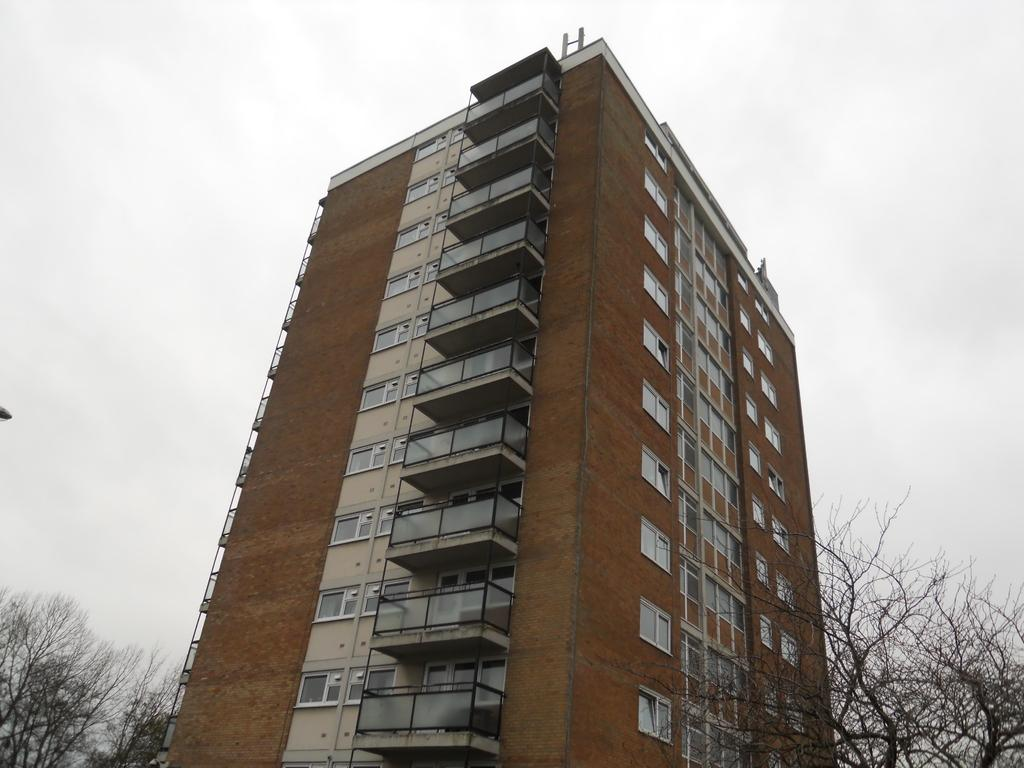What is the main subject in the center of the image? There is a building in the center of the image. What type of natural elements can be seen at the bottom of the image? Trees are visible at the bottom of the image. What part of the natural environment is visible in the background of the image? The sky is visible in the background of the image. Can you tell me what type of legal advice the lawyer is providing in the image? There is no lawyer present in the image, so it is not possible to determine what type of legal advice might be provided. 